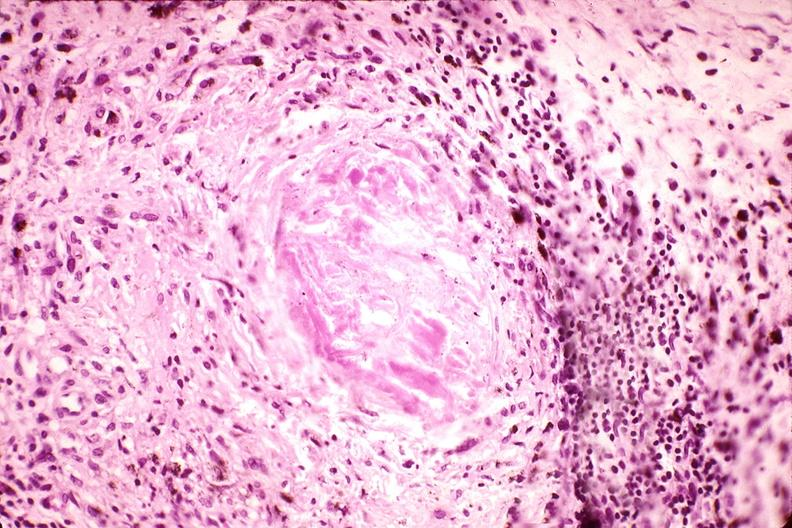s musculoskeletal present?
Answer the question using a single word or phrase. Yes 